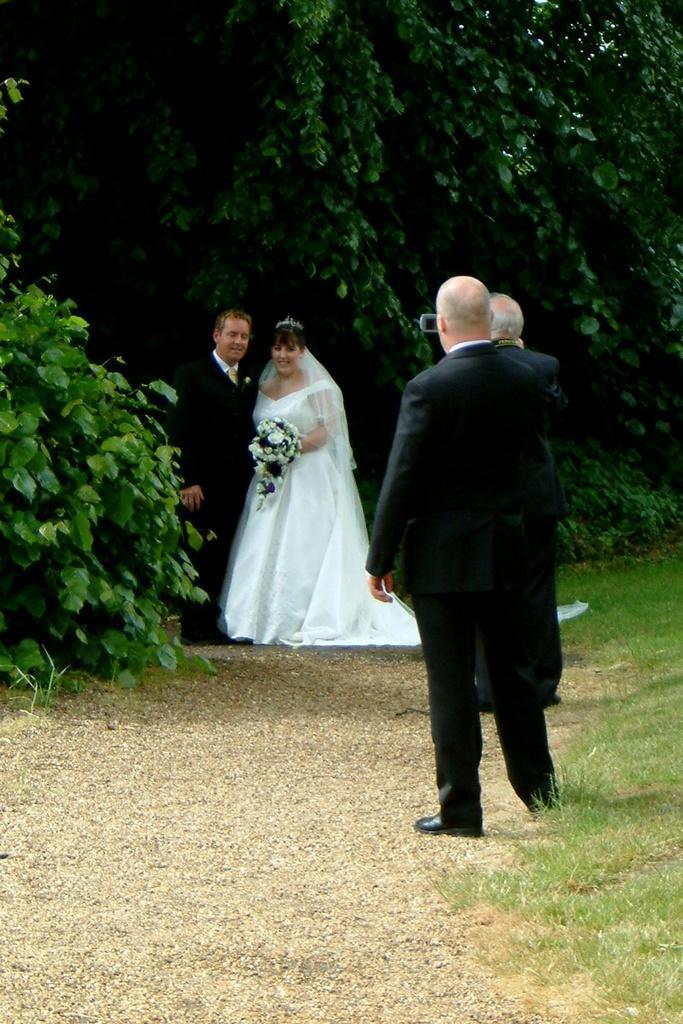Could you give a brief overview of what you see in this image? In this picture I can see a man and a woman standing and smiling, there is a woman holding a bouquet, there are two persons standing, and in the background there are trees. 